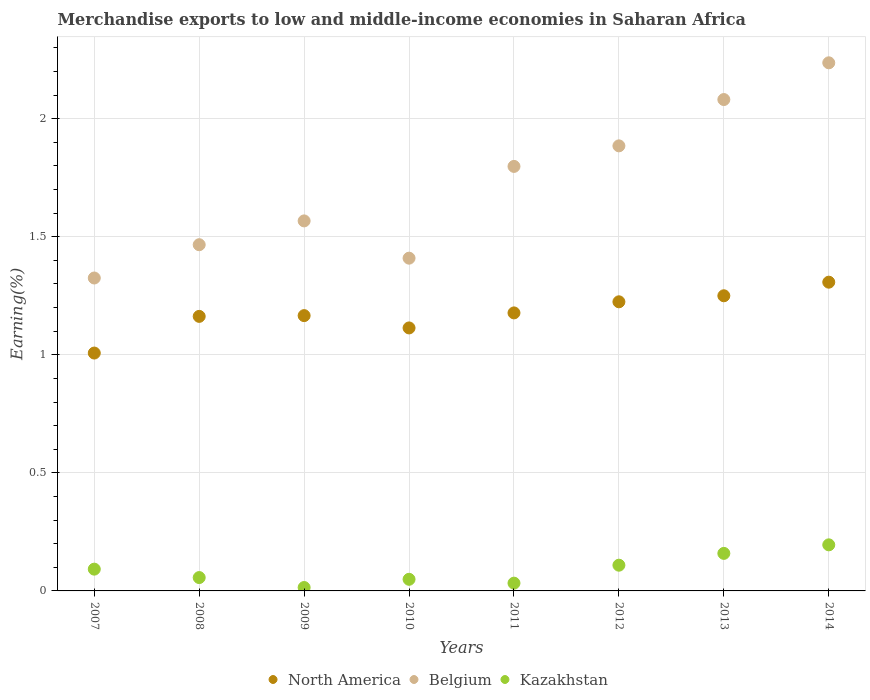How many different coloured dotlines are there?
Give a very brief answer. 3. Is the number of dotlines equal to the number of legend labels?
Your response must be concise. Yes. What is the percentage of amount earned from merchandise exports in North America in 2009?
Offer a very short reply. 1.17. Across all years, what is the maximum percentage of amount earned from merchandise exports in Belgium?
Make the answer very short. 2.24. Across all years, what is the minimum percentage of amount earned from merchandise exports in Kazakhstan?
Your answer should be compact. 0.01. In which year was the percentage of amount earned from merchandise exports in Kazakhstan minimum?
Keep it short and to the point. 2009. What is the total percentage of amount earned from merchandise exports in Belgium in the graph?
Make the answer very short. 13.77. What is the difference between the percentage of amount earned from merchandise exports in North America in 2008 and that in 2014?
Make the answer very short. -0.14. What is the difference between the percentage of amount earned from merchandise exports in Belgium in 2011 and the percentage of amount earned from merchandise exports in North America in 2008?
Provide a short and direct response. 0.64. What is the average percentage of amount earned from merchandise exports in Kazakhstan per year?
Your response must be concise. 0.09. In the year 2009, what is the difference between the percentage of amount earned from merchandise exports in Belgium and percentage of amount earned from merchandise exports in Kazakhstan?
Keep it short and to the point. 1.55. What is the ratio of the percentage of amount earned from merchandise exports in North America in 2007 to that in 2013?
Your answer should be very brief. 0.81. Is the difference between the percentage of amount earned from merchandise exports in Belgium in 2009 and 2010 greater than the difference between the percentage of amount earned from merchandise exports in Kazakhstan in 2009 and 2010?
Your answer should be very brief. Yes. What is the difference between the highest and the second highest percentage of amount earned from merchandise exports in Kazakhstan?
Provide a short and direct response. 0.04. What is the difference between the highest and the lowest percentage of amount earned from merchandise exports in North America?
Your answer should be compact. 0.3. Does the percentage of amount earned from merchandise exports in Belgium monotonically increase over the years?
Offer a very short reply. No. Is the percentage of amount earned from merchandise exports in North America strictly greater than the percentage of amount earned from merchandise exports in Kazakhstan over the years?
Provide a succinct answer. Yes. Is the percentage of amount earned from merchandise exports in North America strictly less than the percentage of amount earned from merchandise exports in Belgium over the years?
Keep it short and to the point. Yes. How many dotlines are there?
Keep it short and to the point. 3. How many years are there in the graph?
Offer a very short reply. 8. Where does the legend appear in the graph?
Offer a very short reply. Bottom center. What is the title of the graph?
Offer a very short reply. Merchandise exports to low and middle-income economies in Saharan Africa. Does "Morocco" appear as one of the legend labels in the graph?
Make the answer very short. No. What is the label or title of the Y-axis?
Ensure brevity in your answer.  Earning(%). What is the Earning(%) of North America in 2007?
Your answer should be very brief. 1.01. What is the Earning(%) of Belgium in 2007?
Your response must be concise. 1.33. What is the Earning(%) of Kazakhstan in 2007?
Provide a short and direct response. 0.09. What is the Earning(%) of North America in 2008?
Your answer should be compact. 1.16. What is the Earning(%) in Belgium in 2008?
Offer a very short reply. 1.47. What is the Earning(%) of Kazakhstan in 2008?
Give a very brief answer. 0.06. What is the Earning(%) of North America in 2009?
Your answer should be very brief. 1.17. What is the Earning(%) of Belgium in 2009?
Ensure brevity in your answer.  1.57. What is the Earning(%) in Kazakhstan in 2009?
Your response must be concise. 0.01. What is the Earning(%) of North America in 2010?
Keep it short and to the point. 1.11. What is the Earning(%) in Belgium in 2010?
Your answer should be very brief. 1.41. What is the Earning(%) of Kazakhstan in 2010?
Offer a terse response. 0.05. What is the Earning(%) in North America in 2011?
Offer a very short reply. 1.18. What is the Earning(%) of Belgium in 2011?
Offer a terse response. 1.8. What is the Earning(%) in Kazakhstan in 2011?
Ensure brevity in your answer.  0.03. What is the Earning(%) of North America in 2012?
Provide a short and direct response. 1.22. What is the Earning(%) of Belgium in 2012?
Keep it short and to the point. 1.89. What is the Earning(%) in Kazakhstan in 2012?
Your response must be concise. 0.11. What is the Earning(%) in North America in 2013?
Offer a very short reply. 1.25. What is the Earning(%) of Belgium in 2013?
Your answer should be very brief. 2.08. What is the Earning(%) in Kazakhstan in 2013?
Your answer should be compact. 0.16. What is the Earning(%) in North America in 2014?
Your answer should be compact. 1.31. What is the Earning(%) in Belgium in 2014?
Your answer should be compact. 2.24. What is the Earning(%) of Kazakhstan in 2014?
Ensure brevity in your answer.  0.2. Across all years, what is the maximum Earning(%) of North America?
Ensure brevity in your answer.  1.31. Across all years, what is the maximum Earning(%) of Belgium?
Ensure brevity in your answer.  2.24. Across all years, what is the maximum Earning(%) of Kazakhstan?
Provide a succinct answer. 0.2. Across all years, what is the minimum Earning(%) in North America?
Ensure brevity in your answer.  1.01. Across all years, what is the minimum Earning(%) in Belgium?
Ensure brevity in your answer.  1.33. Across all years, what is the minimum Earning(%) in Kazakhstan?
Provide a short and direct response. 0.01. What is the total Earning(%) of North America in the graph?
Make the answer very short. 9.41. What is the total Earning(%) of Belgium in the graph?
Provide a short and direct response. 13.77. What is the total Earning(%) of Kazakhstan in the graph?
Your answer should be very brief. 0.71. What is the difference between the Earning(%) in North America in 2007 and that in 2008?
Your response must be concise. -0.16. What is the difference between the Earning(%) of Belgium in 2007 and that in 2008?
Make the answer very short. -0.14. What is the difference between the Earning(%) of Kazakhstan in 2007 and that in 2008?
Give a very brief answer. 0.04. What is the difference between the Earning(%) in North America in 2007 and that in 2009?
Your answer should be compact. -0.16. What is the difference between the Earning(%) of Belgium in 2007 and that in 2009?
Ensure brevity in your answer.  -0.24. What is the difference between the Earning(%) of Kazakhstan in 2007 and that in 2009?
Provide a succinct answer. 0.08. What is the difference between the Earning(%) of North America in 2007 and that in 2010?
Make the answer very short. -0.11. What is the difference between the Earning(%) in Belgium in 2007 and that in 2010?
Make the answer very short. -0.08. What is the difference between the Earning(%) in Kazakhstan in 2007 and that in 2010?
Give a very brief answer. 0.04. What is the difference between the Earning(%) in North America in 2007 and that in 2011?
Your answer should be compact. -0.17. What is the difference between the Earning(%) in Belgium in 2007 and that in 2011?
Provide a short and direct response. -0.47. What is the difference between the Earning(%) of Kazakhstan in 2007 and that in 2011?
Your answer should be compact. 0.06. What is the difference between the Earning(%) in North America in 2007 and that in 2012?
Your answer should be very brief. -0.22. What is the difference between the Earning(%) in Belgium in 2007 and that in 2012?
Your answer should be very brief. -0.56. What is the difference between the Earning(%) of Kazakhstan in 2007 and that in 2012?
Give a very brief answer. -0.02. What is the difference between the Earning(%) of North America in 2007 and that in 2013?
Your answer should be compact. -0.24. What is the difference between the Earning(%) of Belgium in 2007 and that in 2013?
Your answer should be compact. -0.76. What is the difference between the Earning(%) in Kazakhstan in 2007 and that in 2013?
Offer a very short reply. -0.07. What is the difference between the Earning(%) of North America in 2007 and that in 2014?
Ensure brevity in your answer.  -0.3. What is the difference between the Earning(%) of Belgium in 2007 and that in 2014?
Keep it short and to the point. -0.91. What is the difference between the Earning(%) of Kazakhstan in 2007 and that in 2014?
Keep it short and to the point. -0.1. What is the difference between the Earning(%) in North America in 2008 and that in 2009?
Ensure brevity in your answer.  -0. What is the difference between the Earning(%) in Belgium in 2008 and that in 2009?
Offer a very short reply. -0.1. What is the difference between the Earning(%) in Kazakhstan in 2008 and that in 2009?
Offer a very short reply. 0.04. What is the difference between the Earning(%) of North America in 2008 and that in 2010?
Provide a succinct answer. 0.05. What is the difference between the Earning(%) in Belgium in 2008 and that in 2010?
Ensure brevity in your answer.  0.06. What is the difference between the Earning(%) in Kazakhstan in 2008 and that in 2010?
Your answer should be very brief. 0.01. What is the difference between the Earning(%) in North America in 2008 and that in 2011?
Provide a short and direct response. -0.01. What is the difference between the Earning(%) of Belgium in 2008 and that in 2011?
Provide a short and direct response. -0.33. What is the difference between the Earning(%) in Kazakhstan in 2008 and that in 2011?
Provide a short and direct response. 0.02. What is the difference between the Earning(%) in North America in 2008 and that in 2012?
Provide a short and direct response. -0.06. What is the difference between the Earning(%) of Belgium in 2008 and that in 2012?
Provide a succinct answer. -0.42. What is the difference between the Earning(%) in Kazakhstan in 2008 and that in 2012?
Offer a very short reply. -0.05. What is the difference between the Earning(%) in North America in 2008 and that in 2013?
Offer a very short reply. -0.09. What is the difference between the Earning(%) of Belgium in 2008 and that in 2013?
Your answer should be very brief. -0.61. What is the difference between the Earning(%) in Kazakhstan in 2008 and that in 2013?
Your answer should be compact. -0.1. What is the difference between the Earning(%) of North America in 2008 and that in 2014?
Your answer should be compact. -0.14. What is the difference between the Earning(%) in Belgium in 2008 and that in 2014?
Offer a very short reply. -0.77. What is the difference between the Earning(%) in Kazakhstan in 2008 and that in 2014?
Offer a terse response. -0.14. What is the difference between the Earning(%) in North America in 2009 and that in 2010?
Your answer should be compact. 0.05. What is the difference between the Earning(%) of Belgium in 2009 and that in 2010?
Make the answer very short. 0.16. What is the difference between the Earning(%) of Kazakhstan in 2009 and that in 2010?
Keep it short and to the point. -0.03. What is the difference between the Earning(%) of North America in 2009 and that in 2011?
Your response must be concise. -0.01. What is the difference between the Earning(%) in Belgium in 2009 and that in 2011?
Provide a succinct answer. -0.23. What is the difference between the Earning(%) of Kazakhstan in 2009 and that in 2011?
Give a very brief answer. -0.02. What is the difference between the Earning(%) in North America in 2009 and that in 2012?
Offer a very short reply. -0.06. What is the difference between the Earning(%) of Belgium in 2009 and that in 2012?
Give a very brief answer. -0.32. What is the difference between the Earning(%) of Kazakhstan in 2009 and that in 2012?
Provide a succinct answer. -0.09. What is the difference between the Earning(%) of North America in 2009 and that in 2013?
Your answer should be compact. -0.08. What is the difference between the Earning(%) in Belgium in 2009 and that in 2013?
Make the answer very short. -0.51. What is the difference between the Earning(%) in Kazakhstan in 2009 and that in 2013?
Your answer should be very brief. -0.14. What is the difference between the Earning(%) in North America in 2009 and that in 2014?
Give a very brief answer. -0.14. What is the difference between the Earning(%) in Belgium in 2009 and that in 2014?
Keep it short and to the point. -0.67. What is the difference between the Earning(%) in Kazakhstan in 2009 and that in 2014?
Offer a very short reply. -0.18. What is the difference between the Earning(%) of North America in 2010 and that in 2011?
Keep it short and to the point. -0.06. What is the difference between the Earning(%) in Belgium in 2010 and that in 2011?
Your answer should be very brief. -0.39. What is the difference between the Earning(%) in Kazakhstan in 2010 and that in 2011?
Give a very brief answer. 0.02. What is the difference between the Earning(%) of North America in 2010 and that in 2012?
Your answer should be very brief. -0.11. What is the difference between the Earning(%) in Belgium in 2010 and that in 2012?
Keep it short and to the point. -0.48. What is the difference between the Earning(%) of Kazakhstan in 2010 and that in 2012?
Ensure brevity in your answer.  -0.06. What is the difference between the Earning(%) in North America in 2010 and that in 2013?
Provide a short and direct response. -0.14. What is the difference between the Earning(%) of Belgium in 2010 and that in 2013?
Ensure brevity in your answer.  -0.67. What is the difference between the Earning(%) of Kazakhstan in 2010 and that in 2013?
Make the answer very short. -0.11. What is the difference between the Earning(%) in North America in 2010 and that in 2014?
Offer a very short reply. -0.19. What is the difference between the Earning(%) of Belgium in 2010 and that in 2014?
Provide a succinct answer. -0.83. What is the difference between the Earning(%) in Kazakhstan in 2010 and that in 2014?
Make the answer very short. -0.15. What is the difference between the Earning(%) in North America in 2011 and that in 2012?
Offer a very short reply. -0.05. What is the difference between the Earning(%) of Belgium in 2011 and that in 2012?
Your answer should be compact. -0.09. What is the difference between the Earning(%) in Kazakhstan in 2011 and that in 2012?
Give a very brief answer. -0.08. What is the difference between the Earning(%) in North America in 2011 and that in 2013?
Ensure brevity in your answer.  -0.07. What is the difference between the Earning(%) in Belgium in 2011 and that in 2013?
Provide a succinct answer. -0.28. What is the difference between the Earning(%) of Kazakhstan in 2011 and that in 2013?
Provide a short and direct response. -0.13. What is the difference between the Earning(%) in North America in 2011 and that in 2014?
Make the answer very short. -0.13. What is the difference between the Earning(%) in Belgium in 2011 and that in 2014?
Give a very brief answer. -0.44. What is the difference between the Earning(%) in Kazakhstan in 2011 and that in 2014?
Provide a succinct answer. -0.16. What is the difference between the Earning(%) of North America in 2012 and that in 2013?
Provide a short and direct response. -0.03. What is the difference between the Earning(%) of Belgium in 2012 and that in 2013?
Your response must be concise. -0.2. What is the difference between the Earning(%) in North America in 2012 and that in 2014?
Offer a terse response. -0.08. What is the difference between the Earning(%) in Belgium in 2012 and that in 2014?
Ensure brevity in your answer.  -0.35. What is the difference between the Earning(%) in Kazakhstan in 2012 and that in 2014?
Your answer should be very brief. -0.09. What is the difference between the Earning(%) in North America in 2013 and that in 2014?
Ensure brevity in your answer.  -0.06. What is the difference between the Earning(%) of Belgium in 2013 and that in 2014?
Ensure brevity in your answer.  -0.16. What is the difference between the Earning(%) in Kazakhstan in 2013 and that in 2014?
Offer a very short reply. -0.04. What is the difference between the Earning(%) in North America in 2007 and the Earning(%) in Belgium in 2008?
Keep it short and to the point. -0.46. What is the difference between the Earning(%) of North America in 2007 and the Earning(%) of Kazakhstan in 2008?
Ensure brevity in your answer.  0.95. What is the difference between the Earning(%) of Belgium in 2007 and the Earning(%) of Kazakhstan in 2008?
Keep it short and to the point. 1.27. What is the difference between the Earning(%) of North America in 2007 and the Earning(%) of Belgium in 2009?
Offer a terse response. -0.56. What is the difference between the Earning(%) of North America in 2007 and the Earning(%) of Kazakhstan in 2009?
Provide a short and direct response. 0.99. What is the difference between the Earning(%) in Belgium in 2007 and the Earning(%) in Kazakhstan in 2009?
Make the answer very short. 1.31. What is the difference between the Earning(%) of North America in 2007 and the Earning(%) of Belgium in 2010?
Ensure brevity in your answer.  -0.4. What is the difference between the Earning(%) in North America in 2007 and the Earning(%) in Kazakhstan in 2010?
Offer a very short reply. 0.96. What is the difference between the Earning(%) in Belgium in 2007 and the Earning(%) in Kazakhstan in 2010?
Offer a very short reply. 1.28. What is the difference between the Earning(%) in North America in 2007 and the Earning(%) in Belgium in 2011?
Ensure brevity in your answer.  -0.79. What is the difference between the Earning(%) in North America in 2007 and the Earning(%) in Kazakhstan in 2011?
Provide a short and direct response. 0.97. What is the difference between the Earning(%) in Belgium in 2007 and the Earning(%) in Kazakhstan in 2011?
Provide a succinct answer. 1.29. What is the difference between the Earning(%) of North America in 2007 and the Earning(%) of Belgium in 2012?
Your answer should be very brief. -0.88. What is the difference between the Earning(%) of North America in 2007 and the Earning(%) of Kazakhstan in 2012?
Provide a succinct answer. 0.9. What is the difference between the Earning(%) of Belgium in 2007 and the Earning(%) of Kazakhstan in 2012?
Your response must be concise. 1.22. What is the difference between the Earning(%) in North America in 2007 and the Earning(%) in Belgium in 2013?
Provide a short and direct response. -1.07. What is the difference between the Earning(%) in North America in 2007 and the Earning(%) in Kazakhstan in 2013?
Keep it short and to the point. 0.85. What is the difference between the Earning(%) in Belgium in 2007 and the Earning(%) in Kazakhstan in 2013?
Provide a succinct answer. 1.17. What is the difference between the Earning(%) in North America in 2007 and the Earning(%) in Belgium in 2014?
Provide a succinct answer. -1.23. What is the difference between the Earning(%) in North America in 2007 and the Earning(%) in Kazakhstan in 2014?
Provide a succinct answer. 0.81. What is the difference between the Earning(%) in Belgium in 2007 and the Earning(%) in Kazakhstan in 2014?
Make the answer very short. 1.13. What is the difference between the Earning(%) of North America in 2008 and the Earning(%) of Belgium in 2009?
Give a very brief answer. -0.4. What is the difference between the Earning(%) in North America in 2008 and the Earning(%) in Kazakhstan in 2009?
Your response must be concise. 1.15. What is the difference between the Earning(%) in Belgium in 2008 and the Earning(%) in Kazakhstan in 2009?
Your answer should be very brief. 1.45. What is the difference between the Earning(%) in North America in 2008 and the Earning(%) in Belgium in 2010?
Make the answer very short. -0.25. What is the difference between the Earning(%) of North America in 2008 and the Earning(%) of Kazakhstan in 2010?
Offer a terse response. 1.11. What is the difference between the Earning(%) in Belgium in 2008 and the Earning(%) in Kazakhstan in 2010?
Provide a succinct answer. 1.42. What is the difference between the Earning(%) of North America in 2008 and the Earning(%) of Belgium in 2011?
Provide a short and direct response. -0.64. What is the difference between the Earning(%) in North America in 2008 and the Earning(%) in Kazakhstan in 2011?
Make the answer very short. 1.13. What is the difference between the Earning(%) of Belgium in 2008 and the Earning(%) of Kazakhstan in 2011?
Your answer should be very brief. 1.43. What is the difference between the Earning(%) of North America in 2008 and the Earning(%) of Belgium in 2012?
Provide a short and direct response. -0.72. What is the difference between the Earning(%) in North America in 2008 and the Earning(%) in Kazakhstan in 2012?
Give a very brief answer. 1.05. What is the difference between the Earning(%) of Belgium in 2008 and the Earning(%) of Kazakhstan in 2012?
Your answer should be very brief. 1.36. What is the difference between the Earning(%) in North America in 2008 and the Earning(%) in Belgium in 2013?
Your response must be concise. -0.92. What is the difference between the Earning(%) of Belgium in 2008 and the Earning(%) of Kazakhstan in 2013?
Make the answer very short. 1.31. What is the difference between the Earning(%) of North America in 2008 and the Earning(%) of Belgium in 2014?
Your answer should be very brief. -1.07. What is the difference between the Earning(%) of North America in 2008 and the Earning(%) of Kazakhstan in 2014?
Offer a terse response. 0.97. What is the difference between the Earning(%) of Belgium in 2008 and the Earning(%) of Kazakhstan in 2014?
Provide a short and direct response. 1.27. What is the difference between the Earning(%) of North America in 2009 and the Earning(%) of Belgium in 2010?
Your answer should be compact. -0.24. What is the difference between the Earning(%) in North America in 2009 and the Earning(%) in Kazakhstan in 2010?
Provide a short and direct response. 1.12. What is the difference between the Earning(%) in Belgium in 2009 and the Earning(%) in Kazakhstan in 2010?
Offer a terse response. 1.52. What is the difference between the Earning(%) in North America in 2009 and the Earning(%) in Belgium in 2011?
Provide a short and direct response. -0.63. What is the difference between the Earning(%) of North America in 2009 and the Earning(%) of Kazakhstan in 2011?
Give a very brief answer. 1.13. What is the difference between the Earning(%) of Belgium in 2009 and the Earning(%) of Kazakhstan in 2011?
Offer a very short reply. 1.53. What is the difference between the Earning(%) of North America in 2009 and the Earning(%) of Belgium in 2012?
Keep it short and to the point. -0.72. What is the difference between the Earning(%) in North America in 2009 and the Earning(%) in Kazakhstan in 2012?
Keep it short and to the point. 1.06. What is the difference between the Earning(%) in Belgium in 2009 and the Earning(%) in Kazakhstan in 2012?
Ensure brevity in your answer.  1.46. What is the difference between the Earning(%) of North America in 2009 and the Earning(%) of Belgium in 2013?
Give a very brief answer. -0.92. What is the difference between the Earning(%) of Belgium in 2009 and the Earning(%) of Kazakhstan in 2013?
Keep it short and to the point. 1.41. What is the difference between the Earning(%) of North America in 2009 and the Earning(%) of Belgium in 2014?
Ensure brevity in your answer.  -1.07. What is the difference between the Earning(%) of North America in 2009 and the Earning(%) of Kazakhstan in 2014?
Make the answer very short. 0.97. What is the difference between the Earning(%) of Belgium in 2009 and the Earning(%) of Kazakhstan in 2014?
Offer a very short reply. 1.37. What is the difference between the Earning(%) of North America in 2010 and the Earning(%) of Belgium in 2011?
Make the answer very short. -0.68. What is the difference between the Earning(%) in North America in 2010 and the Earning(%) in Kazakhstan in 2011?
Offer a very short reply. 1.08. What is the difference between the Earning(%) of Belgium in 2010 and the Earning(%) of Kazakhstan in 2011?
Provide a succinct answer. 1.38. What is the difference between the Earning(%) in North America in 2010 and the Earning(%) in Belgium in 2012?
Provide a succinct answer. -0.77. What is the difference between the Earning(%) of North America in 2010 and the Earning(%) of Kazakhstan in 2012?
Provide a succinct answer. 1. What is the difference between the Earning(%) of Belgium in 2010 and the Earning(%) of Kazakhstan in 2012?
Provide a succinct answer. 1.3. What is the difference between the Earning(%) in North America in 2010 and the Earning(%) in Belgium in 2013?
Your response must be concise. -0.97. What is the difference between the Earning(%) in North America in 2010 and the Earning(%) in Kazakhstan in 2013?
Your answer should be very brief. 0.95. What is the difference between the Earning(%) of Belgium in 2010 and the Earning(%) of Kazakhstan in 2013?
Offer a very short reply. 1.25. What is the difference between the Earning(%) in North America in 2010 and the Earning(%) in Belgium in 2014?
Make the answer very short. -1.12. What is the difference between the Earning(%) in North America in 2010 and the Earning(%) in Kazakhstan in 2014?
Your response must be concise. 0.92. What is the difference between the Earning(%) in Belgium in 2010 and the Earning(%) in Kazakhstan in 2014?
Your answer should be very brief. 1.21. What is the difference between the Earning(%) of North America in 2011 and the Earning(%) of Belgium in 2012?
Offer a very short reply. -0.71. What is the difference between the Earning(%) of North America in 2011 and the Earning(%) of Kazakhstan in 2012?
Offer a very short reply. 1.07. What is the difference between the Earning(%) of Belgium in 2011 and the Earning(%) of Kazakhstan in 2012?
Your answer should be very brief. 1.69. What is the difference between the Earning(%) in North America in 2011 and the Earning(%) in Belgium in 2013?
Make the answer very short. -0.9. What is the difference between the Earning(%) of North America in 2011 and the Earning(%) of Kazakhstan in 2013?
Your answer should be very brief. 1.02. What is the difference between the Earning(%) of Belgium in 2011 and the Earning(%) of Kazakhstan in 2013?
Your response must be concise. 1.64. What is the difference between the Earning(%) of North America in 2011 and the Earning(%) of Belgium in 2014?
Make the answer very short. -1.06. What is the difference between the Earning(%) of North America in 2011 and the Earning(%) of Kazakhstan in 2014?
Provide a short and direct response. 0.98. What is the difference between the Earning(%) in Belgium in 2011 and the Earning(%) in Kazakhstan in 2014?
Offer a terse response. 1.6. What is the difference between the Earning(%) in North America in 2012 and the Earning(%) in Belgium in 2013?
Keep it short and to the point. -0.86. What is the difference between the Earning(%) of North America in 2012 and the Earning(%) of Kazakhstan in 2013?
Your answer should be compact. 1.07. What is the difference between the Earning(%) of Belgium in 2012 and the Earning(%) of Kazakhstan in 2013?
Your response must be concise. 1.73. What is the difference between the Earning(%) in North America in 2012 and the Earning(%) in Belgium in 2014?
Give a very brief answer. -1.01. What is the difference between the Earning(%) in North America in 2012 and the Earning(%) in Kazakhstan in 2014?
Make the answer very short. 1.03. What is the difference between the Earning(%) of Belgium in 2012 and the Earning(%) of Kazakhstan in 2014?
Ensure brevity in your answer.  1.69. What is the difference between the Earning(%) in North America in 2013 and the Earning(%) in Belgium in 2014?
Offer a terse response. -0.99. What is the difference between the Earning(%) of North America in 2013 and the Earning(%) of Kazakhstan in 2014?
Give a very brief answer. 1.05. What is the difference between the Earning(%) of Belgium in 2013 and the Earning(%) of Kazakhstan in 2014?
Provide a succinct answer. 1.89. What is the average Earning(%) of North America per year?
Provide a succinct answer. 1.18. What is the average Earning(%) in Belgium per year?
Make the answer very short. 1.72. What is the average Earning(%) in Kazakhstan per year?
Your response must be concise. 0.09. In the year 2007, what is the difference between the Earning(%) of North America and Earning(%) of Belgium?
Make the answer very short. -0.32. In the year 2007, what is the difference between the Earning(%) in North America and Earning(%) in Kazakhstan?
Provide a short and direct response. 0.92. In the year 2007, what is the difference between the Earning(%) in Belgium and Earning(%) in Kazakhstan?
Your answer should be compact. 1.23. In the year 2008, what is the difference between the Earning(%) in North America and Earning(%) in Belgium?
Offer a very short reply. -0.3. In the year 2008, what is the difference between the Earning(%) of North America and Earning(%) of Kazakhstan?
Offer a terse response. 1.11. In the year 2008, what is the difference between the Earning(%) in Belgium and Earning(%) in Kazakhstan?
Offer a very short reply. 1.41. In the year 2009, what is the difference between the Earning(%) in North America and Earning(%) in Belgium?
Offer a terse response. -0.4. In the year 2009, what is the difference between the Earning(%) of North America and Earning(%) of Kazakhstan?
Offer a very short reply. 1.15. In the year 2009, what is the difference between the Earning(%) in Belgium and Earning(%) in Kazakhstan?
Offer a terse response. 1.55. In the year 2010, what is the difference between the Earning(%) in North America and Earning(%) in Belgium?
Your answer should be compact. -0.3. In the year 2010, what is the difference between the Earning(%) of North America and Earning(%) of Kazakhstan?
Provide a short and direct response. 1.06. In the year 2010, what is the difference between the Earning(%) in Belgium and Earning(%) in Kazakhstan?
Your response must be concise. 1.36. In the year 2011, what is the difference between the Earning(%) in North America and Earning(%) in Belgium?
Make the answer very short. -0.62. In the year 2011, what is the difference between the Earning(%) of North America and Earning(%) of Kazakhstan?
Ensure brevity in your answer.  1.14. In the year 2011, what is the difference between the Earning(%) of Belgium and Earning(%) of Kazakhstan?
Provide a short and direct response. 1.77. In the year 2012, what is the difference between the Earning(%) in North America and Earning(%) in Belgium?
Ensure brevity in your answer.  -0.66. In the year 2012, what is the difference between the Earning(%) of North America and Earning(%) of Kazakhstan?
Your answer should be compact. 1.12. In the year 2012, what is the difference between the Earning(%) of Belgium and Earning(%) of Kazakhstan?
Keep it short and to the point. 1.78. In the year 2013, what is the difference between the Earning(%) of North America and Earning(%) of Belgium?
Ensure brevity in your answer.  -0.83. In the year 2013, what is the difference between the Earning(%) of North America and Earning(%) of Kazakhstan?
Your response must be concise. 1.09. In the year 2013, what is the difference between the Earning(%) in Belgium and Earning(%) in Kazakhstan?
Your response must be concise. 1.92. In the year 2014, what is the difference between the Earning(%) in North America and Earning(%) in Belgium?
Offer a very short reply. -0.93. In the year 2014, what is the difference between the Earning(%) in North America and Earning(%) in Kazakhstan?
Give a very brief answer. 1.11. In the year 2014, what is the difference between the Earning(%) in Belgium and Earning(%) in Kazakhstan?
Offer a very short reply. 2.04. What is the ratio of the Earning(%) of North America in 2007 to that in 2008?
Keep it short and to the point. 0.87. What is the ratio of the Earning(%) in Belgium in 2007 to that in 2008?
Ensure brevity in your answer.  0.9. What is the ratio of the Earning(%) of Kazakhstan in 2007 to that in 2008?
Your answer should be very brief. 1.63. What is the ratio of the Earning(%) in North America in 2007 to that in 2009?
Your answer should be very brief. 0.86. What is the ratio of the Earning(%) of Belgium in 2007 to that in 2009?
Ensure brevity in your answer.  0.85. What is the ratio of the Earning(%) of Kazakhstan in 2007 to that in 2009?
Make the answer very short. 6.41. What is the ratio of the Earning(%) of North America in 2007 to that in 2010?
Your answer should be very brief. 0.9. What is the ratio of the Earning(%) of Belgium in 2007 to that in 2010?
Give a very brief answer. 0.94. What is the ratio of the Earning(%) of Kazakhstan in 2007 to that in 2010?
Your response must be concise. 1.87. What is the ratio of the Earning(%) of North America in 2007 to that in 2011?
Keep it short and to the point. 0.86. What is the ratio of the Earning(%) in Belgium in 2007 to that in 2011?
Your answer should be compact. 0.74. What is the ratio of the Earning(%) of Kazakhstan in 2007 to that in 2011?
Give a very brief answer. 2.8. What is the ratio of the Earning(%) in North America in 2007 to that in 2012?
Ensure brevity in your answer.  0.82. What is the ratio of the Earning(%) in Belgium in 2007 to that in 2012?
Offer a very short reply. 0.7. What is the ratio of the Earning(%) of Kazakhstan in 2007 to that in 2012?
Your response must be concise. 0.85. What is the ratio of the Earning(%) in North America in 2007 to that in 2013?
Ensure brevity in your answer.  0.81. What is the ratio of the Earning(%) of Belgium in 2007 to that in 2013?
Your answer should be compact. 0.64. What is the ratio of the Earning(%) in Kazakhstan in 2007 to that in 2013?
Give a very brief answer. 0.58. What is the ratio of the Earning(%) in North America in 2007 to that in 2014?
Offer a terse response. 0.77. What is the ratio of the Earning(%) of Belgium in 2007 to that in 2014?
Give a very brief answer. 0.59. What is the ratio of the Earning(%) of Kazakhstan in 2007 to that in 2014?
Ensure brevity in your answer.  0.47. What is the ratio of the Earning(%) in North America in 2008 to that in 2009?
Provide a short and direct response. 1. What is the ratio of the Earning(%) in Belgium in 2008 to that in 2009?
Make the answer very short. 0.94. What is the ratio of the Earning(%) in Kazakhstan in 2008 to that in 2009?
Offer a very short reply. 3.93. What is the ratio of the Earning(%) of North America in 2008 to that in 2010?
Provide a succinct answer. 1.04. What is the ratio of the Earning(%) in Belgium in 2008 to that in 2010?
Offer a very short reply. 1.04. What is the ratio of the Earning(%) in Kazakhstan in 2008 to that in 2010?
Your answer should be compact. 1.15. What is the ratio of the Earning(%) in North America in 2008 to that in 2011?
Offer a very short reply. 0.99. What is the ratio of the Earning(%) of Belgium in 2008 to that in 2011?
Your answer should be very brief. 0.82. What is the ratio of the Earning(%) of Kazakhstan in 2008 to that in 2011?
Offer a very short reply. 1.72. What is the ratio of the Earning(%) in North America in 2008 to that in 2012?
Offer a very short reply. 0.95. What is the ratio of the Earning(%) of Belgium in 2008 to that in 2012?
Your response must be concise. 0.78. What is the ratio of the Earning(%) in Kazakhstan in 2008 to that in 2012?
Keep it short and to the point. 0.52. What is the ratio of the Earning(%) of North America in 2008 to that in 2013?
Give a very brief answer. 0.93. What is the ratio of the Earning(%) of Belgium in 2008 to that in 2013?
Your answer should be compact. 0.7. What is the ratio of the Earning(%) in Kazakhstan in 2008 to that in 2013?
Offer a terse response. 0.36. What is the ratio of the Earning(%) of North America in 2008 to that in 2014?
Give a very brief answer. 0.89. What is the ratio of the Earning(%) in Belgium in 2008 to that in 2014?
Offer a very short reply. 0.66. What is the ratio of the Earning(%) of Kazakhstan in 2008 to that in 2014?
Your response must be concise. 0.29. What is the ratio of the Earning(%) of North America in 2009 to that in 2010?
Offer a terse response. 1.05. What is the ratio of the Earning(%) of Belgium in 2009 to that in 2010?
Offer a very short reply. 1.11. What is the ratio of the Earning(%) in Kazakhstan in 2009 to that in 2010?
Your answer should be very brief. 0.29. What is the ratio of the Earning(%) of North America in 2009 to that in 2011?
Provide a succinct answer. 0.99. What is the ratio of the Earning(%) in Belgium in 2009 to that in 2011?
Ensure brevity in your answer.  0.87. What is the ratio of the Earning(%) in Kazakhstan in 2009 to that in 2011?
Offer a terse response. 0.44. What is the ratio of the Earning(%) in North America in 2009 to that in 2012?
Make the answer very short. 0.95. What is the ratio of the Earning(%) of Belgium in 2009 to that in 2012?
Provide a succinct answer. 0.83. What is the ratio of the Earning(%) of Kazakhstan in 2009 to that in 2012?
Your response must be concise. 0.13. What is the ratio of the Earning(%) of North America in 2009 to that in 2013?
Your answer should be very brief. 0.93. What is the ratio of the Earning(%) in Belgium in 2009 to that in 2013?
Provide a short and direct response. 0.75. What is the ratio of the Earning(%) in Kazakhstan in 2009 to that in 2013?
Your response must be concise. 0.09. What is the ratio of the Earning(%) of North America in 2009 to that in 2014?
Offer a terse response. 0.89. What is the ratio of the Earning(%) in Belgium in 2009 to that in 2014?
Provide a short and direct response. 0.7. What is the ratio of the Earning(%) of Kazakhstan in 2009 to that in 2014?
Your response must be concise. 0.07. What is the ratio of the Earning(%) of North America in 2010 to that in 2011?
Ensure brevity in your answer.  0.95. What is the ratio of the Earning(%) in Belgium in 2010 to that in 2011?
Make the answer very short. 0.78. What is the ratio of the Earning(%) of Kazakhstan in 2010 to that in 2011?
Your response must be concise. 1.49. What is the ratio of the Earning(%) of North America in 2010 to that in 2012?
Provide a succinct answer. 0.91. What is the ratio of the Earning(%) in Belgium in 2010 to that in 2012?
Provide a succinct answer. 0.75. What is the ratio of the Earning(%) of Kazakhstan in 2010 to that in 2012?
Provide a succinct answer. 0.45. What is the ratio of the Earning(%) of North America in 2010 to that in 2013?
Offer a terse response. 0.89. What is the ratio of the Earning(%) of Belgium in 2010 to that in 2013?
Make the answer very short. 0.68. What is the ratio of the Earning(%) in Kazakhstan in 2010 to that in 2013?
Offer a very short reply. 0.31. What is the ratio of the Earning(%) in North America in 2010 to that in 2014?
Your answer should be very brief. 0.85. What is the ratio of the Earning(%) of Belgium in 2010 to that in 2014?
Your response must be concise. 0.63. What is the ratio of the Earning(%) in Kazakhstan in 2010 to that in 2014?
Your answer should be compact. 0.25. What is the ratio of the Earning(%) in North America in 2011 to that in 2012?
Make the answer very short. 0.96. What is the ratio of the Earning(%) in Belgium in 2011 to that in 2012?
Provide a short and direct response. 0.95. What is the ratio of the Earning(%) in Kazakhstan in 2011 to that in 2012?
Your answer should be very brief. 0.3. What is the ratio of the Earning(%) in North America in 2011 to that in 2013?
Your answer should be compact. 0.94. What is the ratio of the Earning(%) of Belgium in 2011 to that in 2013?
Keep it short and to the point. 0.86. What is the ratio of the Earning(%) in Kazakhstan in 2011 to that in 2013?
Provide a succinct answer. 0.21. What is the ratio of the Earning(%) in North America in 2011 to that in 2014?
Make the answer very short. 0.9. What is the ratio of the Earning(%) in Belgium in 2011 to that in 2014?
Provide a short and direct response. 0.8. What is the ratio of the Earning(%) in Kazakhstan in 2011 to that in 2014?
Keep it short and to the point. 0.17. What is the ratio of the Earning(%) of North America in 2012 to that in 2013?
Offer a terse response. 0.98. What is the ratio of the Earning(%) in Belgium in 2012 to that in 2013?
Your response must be concise. 0.91. What is the ratio of the Earning(%) of Kazakhstan in 2012 to that in 2013?
Your response must be concise. 0.69. What is the ratio of the Earning(%) of North America in 2012 to that in 2014?
Ensure brevity in your answer.  0.94. What is the ratio of the Earning(%) of Belgium in 2012 to that in 2014?
Offer a very short reply. 0.84. What is the ratio of the Earning(%) of Kazakhstan in 2012 to that in 2014?
Ensure brevity in your answer.  0.56. What is the ratio of the Earning(%) of North America in 2013 to that in 2014?
Ensure brevity in your answer.  0.96. What is the ratio of the Earning(%) of Belgium in 2013 to that in 2014?
Keep it short and to the point. 0.93. What is the ratio of the Earning(%) of Kazakhstan in 2013 to that in 2014?
Ensure brevity in your answer.  0.81. What is the difference between the highest and the second highest Earning(%) of North America?
Make the answer very short. 0.06. What is the difference between the highest and the second highest Earning(%) of Belgium?
Make the answer very short. 0.16. What is the difference between the highest and the second highest Earning(%) in Kazakhstan?
Provide a succinct answer. 0.04. What is the difference between the highest and the lowest Earning(%) in North America?
Provide a short and direct response. 0.3. What is the difference between the highest and the lowest Earning(%) of Belgium?
Your answer should be very brief. 0.91. What is the difference between the highest and the lowest Earning(%) of Kazakhstan?
Provide a succinct answer. 0.18. 